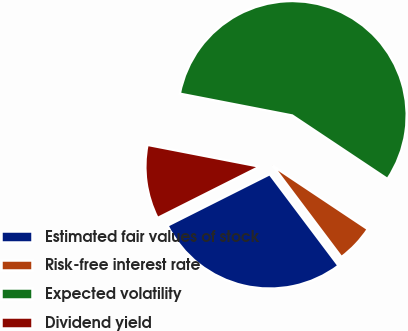Convert chart. <chart><loc_0><loc_0><loc_500><loc_500><pie_chart><fcel>Estimated fair values of stock<fcel>Risk-free interest rate<fcel>Expected volatility<fcel>Dividend yield<nl><fcel>27.84%<fcel>5.38%<fcel>56.31%<fcel>10.47%<nl></chart> 